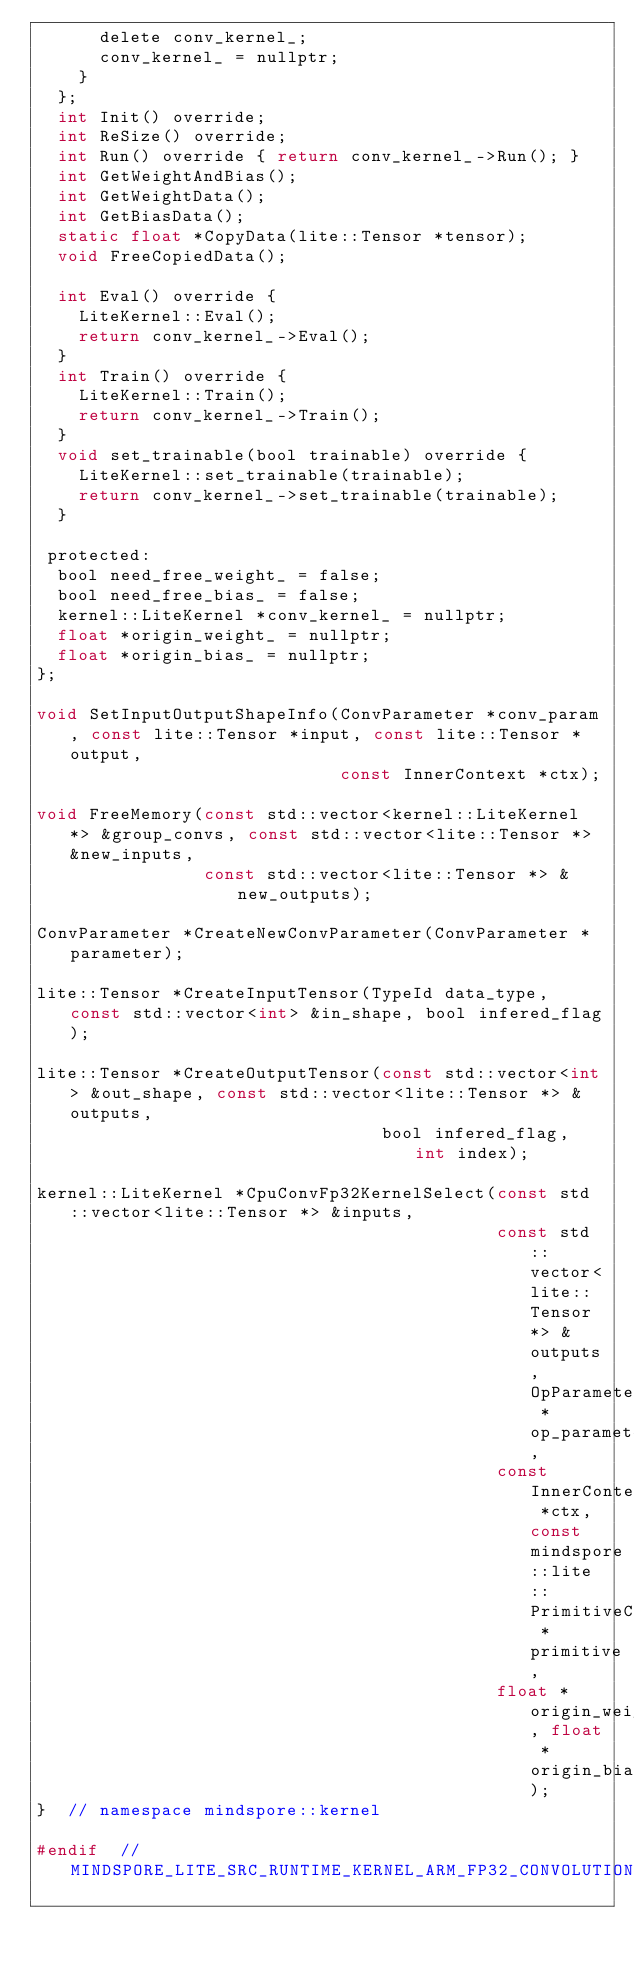Convert code to text. <code><loc_0><loc_0><loc_500><loc_500><_C_>      delete conv_kernel_;
      conv_kernel_ = nullptr;
    }
  };
  int Init() override;
  int ReSize() override;
  int Run() override { return conv_kernel_->Run(); }
  int GetWeightAndBias();
  int GetWeightData();
  int GetBiasData();
  static float *CopyData(lite::Tensor *tensor);
  void FreeCopiedData();

  int Eval() override {
    LiteKernel::Eval();
    return conv_kernel_->Eval();
  }
  int Train() override {
    LiteKernel::Train();
    return conv_kernel_->Train();
  }
  void set_trainable(bool trainable) override {
    LiteKernel::set_trainable(trainable);
    return conv_kernel_->set_trainable(trainable);
  }

 protected:
  bool need_free_weight_ = false;
  bool need_free_bias_ = false;
  kernel::LiteKernel *conv_kernel_ = nullptr;
  float *origin_weight_ = nullptr;
  float *origin_bias_ = nullptr;
};

void SetInputOutputShapeInfo(ConvParameter *conv_param, const lite::Tensor *input, const lite::Tensor *output,
                             const InnerContext *ctx);

void FreeMemory(const std::vector<kernel::LiteKernel *> &group_convs, const std::vector<lite::Tensor *> &new_inputs,
                const std::vector<lite::Tensor *> &new_outputs);

ConvParameter *CreateNewConvParameter(ConvParameter *parameter);

lite::Tensor *CreateInputTensor(TypeId data_type, const std::vector<int> &in_shape, bool infered_flag);

lite::Tensor *CreateOutputTensor(const std::vector<int> &out_shape, const std::vector<lite::Tensor *> &outputs,
                                 bool infered_flag, int index);

kernel::LiteKernel *CpuConvFp32KernelSelect(const std::vector<lite::Tensor *> &inputs,
                                            const std::vector<lite::Tensor *> &outputs, OpParameter *op_parameter,
                                            const InnerContext *ctx, const mindspore::lite::PrimitiveC *primitive,
                                            float *origin_weight, float *origin_bias);
}  // namespace mindspore::kernel

#endif  // MINDSPORE_LITE_SRC_RUNTIME_KERNEL_ARM_FP32_CONVOLUTION_DELEGATE_FP32_H_
</code> 